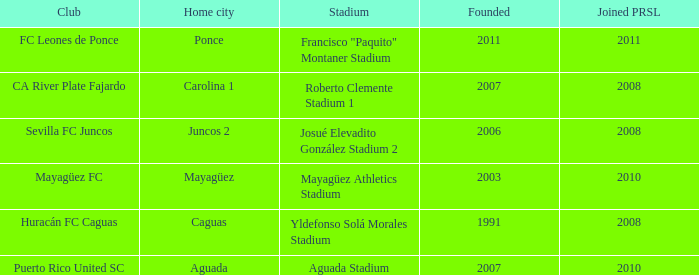Can you parse all the data within this table? {'header': ['Club', 'Home city', 'Stadium', 'Founded', 'Joined PRSL'], 'rows': [['FC Leones de Ponce', 'Ponce', 'Francisco "Paquito" Montaner Stadium', '2011', '2011'], ['CA River Plate Fajardo', 'Carolina 1', 'Roberto Clemente Stadium 1', '2007', '2008'], ['Sevilla FC Juncos', 'Juncos 2', 'Josué Elevadito González Stadium 2', '2006', '2008'], ['Mayagüez FC', 'Mayagüez', 'Mayagüez Athletics Stadium', '2003', '2010'], ['Huracán FC Caguas', 'Caguas', 'Yldefonso Solá Morales Stadium', '1991', '2008'], ['Puerto Rico United SC', 'Aguada', 'Aguada Stadium', '2007', '2010']]} When is the latest to join prsl when founded in 2007 and the stadium is roberto clemente stadium 1? 2008.0. 